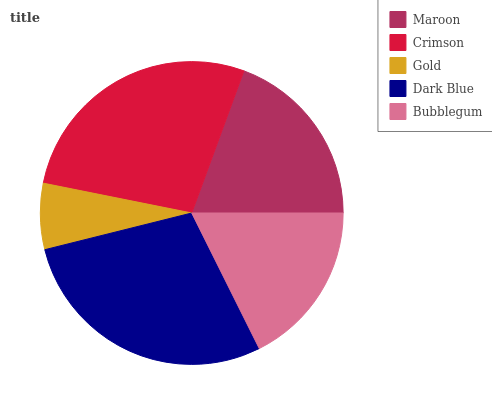Is Gold the minimum?
Answer yes or no. Yes. Is Dark Blue the maximum?
Answer yes or no. Yes. Is Crimson the minimum?
Answer yes or no. No. Is Crimson the maximum?
Answer yes or no. No. Is Crimson greater than Maroon?
Answer yes or no. Yes. Is Maroon less than Crimson?
Answer yes or no. Yes. Is Maroon greater than Crimson?
Answer yes or no. No. Is Crimson less than Maroon?
Answer yes or no. No. Is Maroon the high median?
Answer yes or no. Yes. Is Maroon the low median?
Answer yes or no. Yes. Is Dark Blue the high median?
Answer yes or no. No. Is Bubblegum the low median?
Answer yes or no. No. 